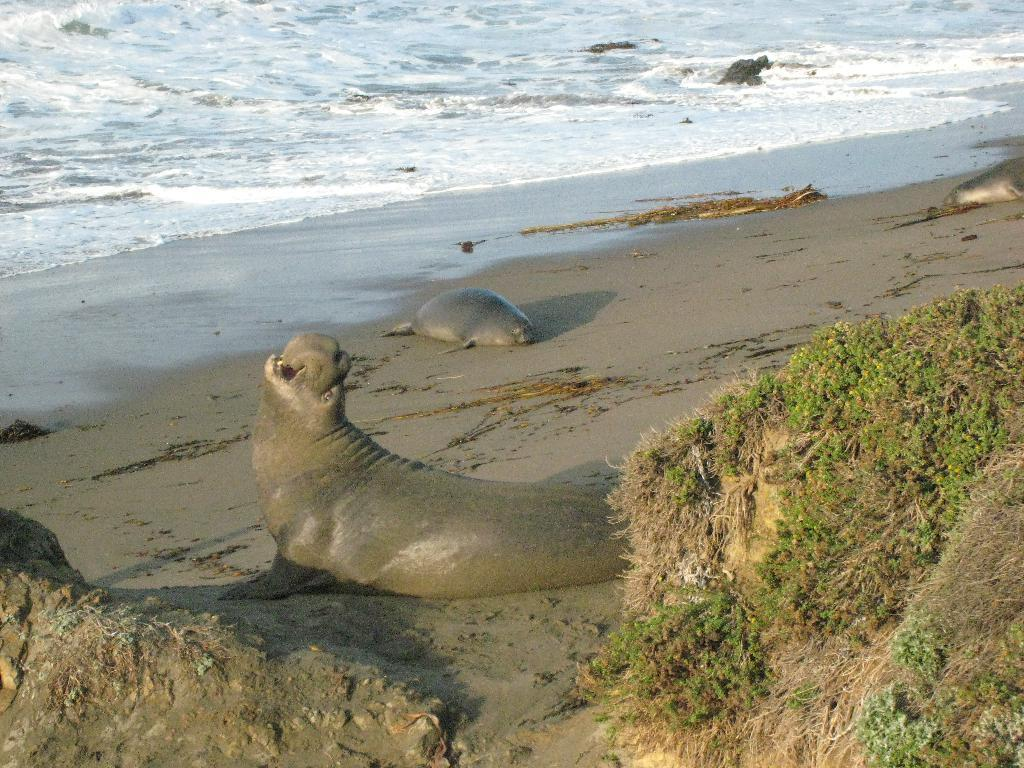What animals can be seen on the sand in the image? There are elephant seals on the sand in the image. What type of vegetation is visible on the right side of the image? There is grass on the right side of the image. What natural feature can be seen in the background of the image? There is a river in the background of the image. What type of sponge is being used to clean the throat of the elephant seals in the image? There is no sponge or throat-cleaning activity present in the image; it features elephant seals on the sand with grass and a river in the background. 